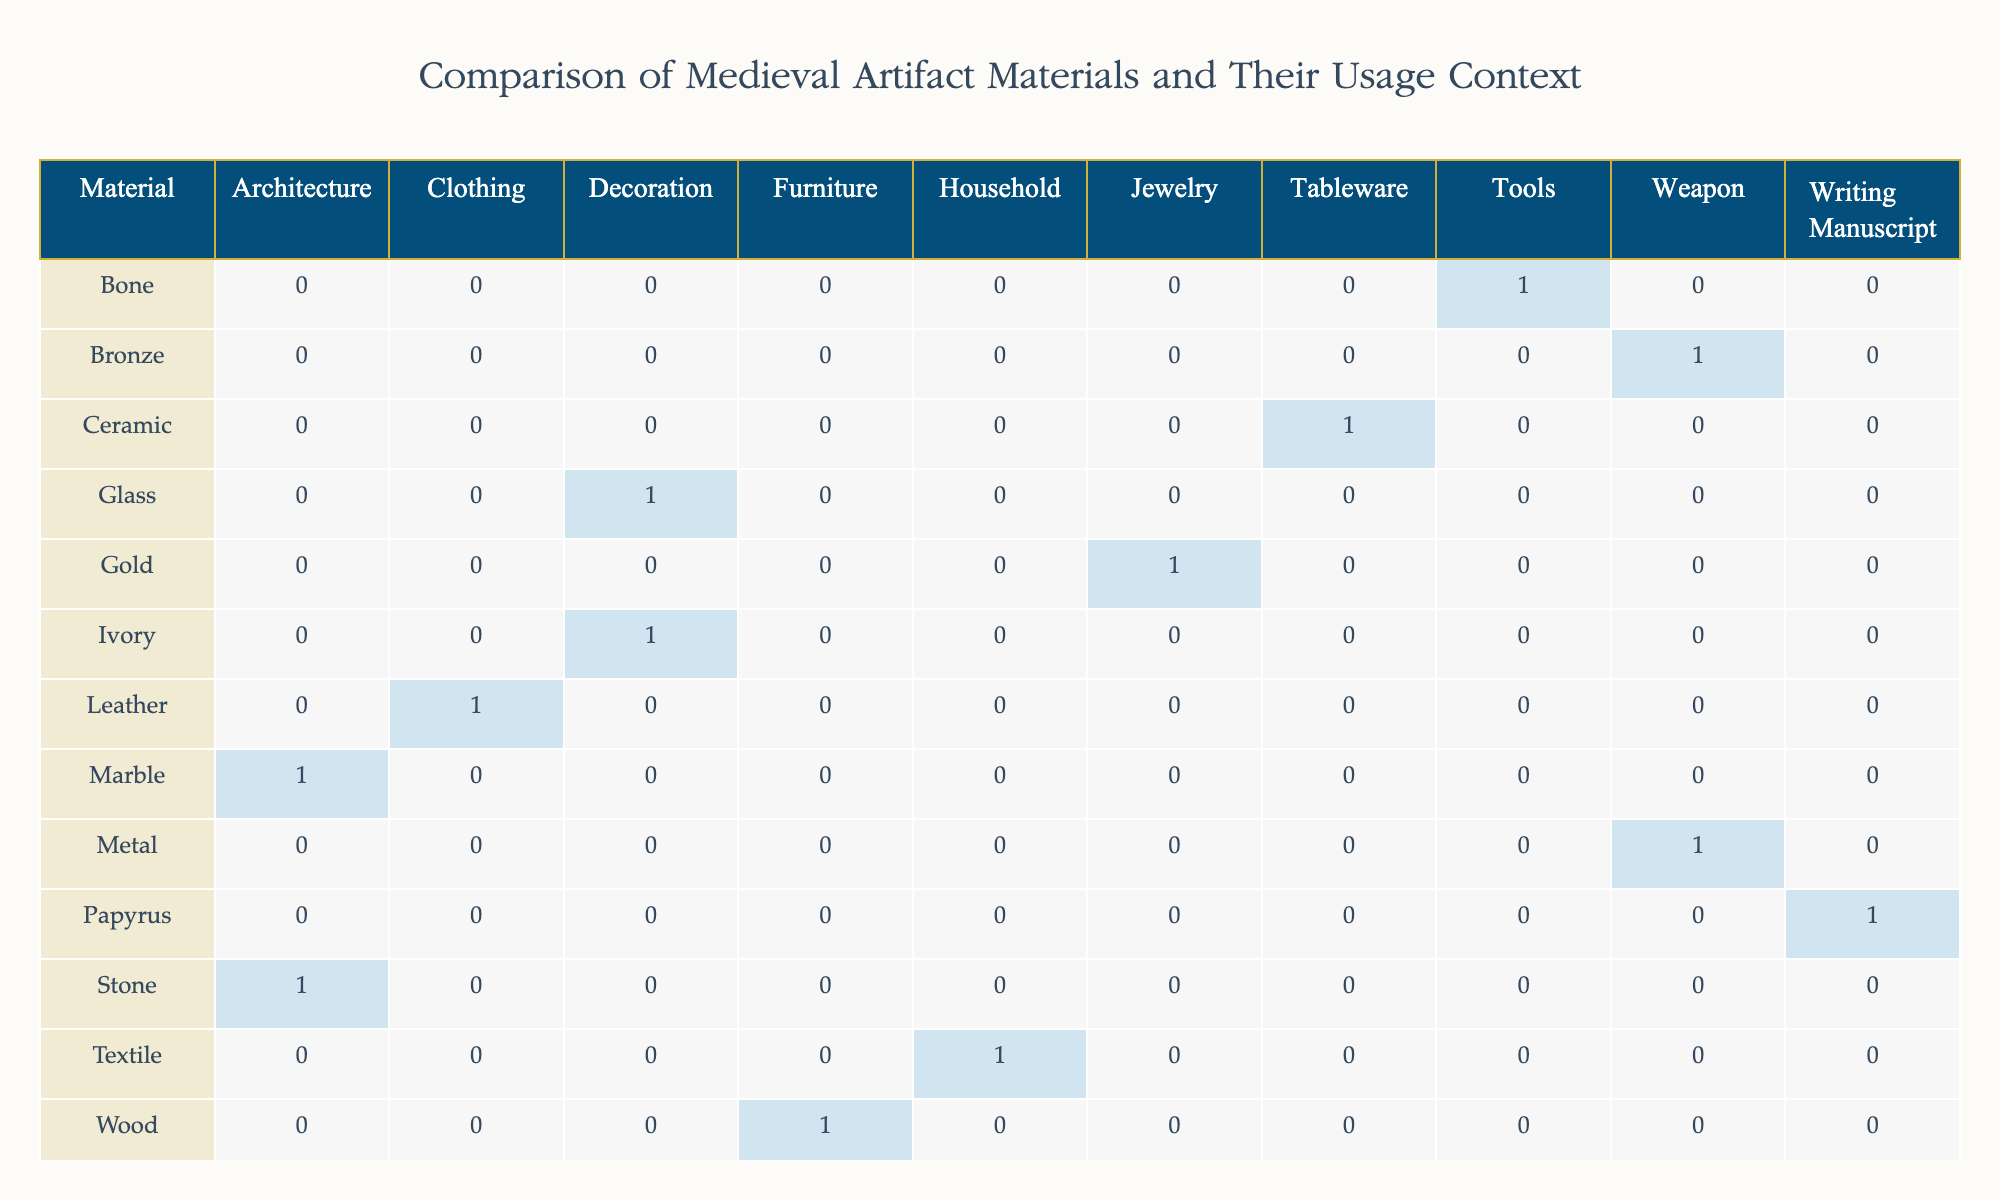What materials are used for clothing artifacts? Looking at the 'Usage Context' column, the only material listed that corresponds with 'Clothing' is 'Leather', which is used for 'Boots'.
Answer: Leather How many artifact types are made from metal? The table indicates that there are two artifact types made from metal: 'Sword' and 'Spearhead'. Therefore, we count them: Sword (1) + Spearhead (1) = 2.
Answer: 2 Is there any artifact type made from bone? Checking the 'Artifact Type' corresponding to 'Bone' in the table, it states 'Needle', confirming that there is indeed an artifact type made from bone.
Answer: Yes What is the most common usage context for wood artifacts? Referring to the table, wood is only associated with the 'Furniture' context for the 'Table' type. Thus, the most common context for wood artifacts is 'Furniture'.
Answer: Furniture How many total artifacts are listed for Western Europe? The table lists the artifact types for Western Europe: 'Sword', 'Boots', and 'Spearhead'. Counting these gives us: Sword (1) + Boots (1) + Spearhead (1) = 3.
Answer: 3 Which material has the largest variety of usage contexts based on this data? By analyzing the table, we see that 'Wood', 'Metal', 'Ceramic', 'Glass', 'Stone', 'Leather', 'Textile', 'Bone', 'Ivory', 'Bronze', 'Gold', 'Papyrus', and 'Marble' feature only in singular usage contexts each. Therefore, no material has a larger variety than 1 context.
Answer: None Which regions have items made from ivory and what is their usage context? The table shows that 'Ivory' is associated with 'Decoration' and the corresponding region is listed as 'Middle East'. Therefore, the region with ivory artifacts is Middle East, used for decoration.
Answer: Middle East, Decoration How many types of artifacts are categorized under architecture? In the table, the 'Architecture' context includes 'Column' (made of Stone) and 'Statue' (made of Marble). Counting these, we find 2 types of artifacts fit this category.
Answer: 2 What is the difference in the number of artifacts associated with decorative contexts versus writing contexts? The table lists 'Vase' and 'Carving' in decorative contexts, totaling 2 artifacts. The writing context includes 'Book', counting 1 artifact. The difference is therefore 2 (decorative) - 1 (writing) = 1.
Answer: 1 